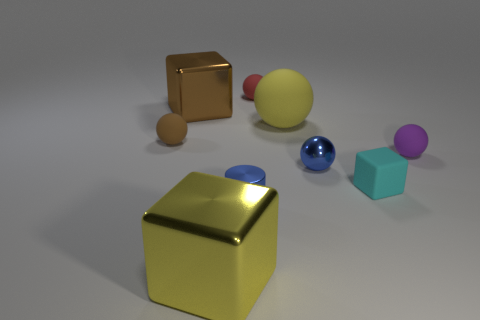Subtract all brown cubes. How many cubes are left? 2 Subtract all red balls. How many balls are left? 4 Add 1 purple objects. How many objects exist? 10 Subtract 2 cubes. How many cubes are left? 1 Subtract all cylinders. How many objects are left? 8 Subtract all green blocks. Subtract all green cylinders. How many blocks are left? 3 Subtract all large yellow blocks. Subtract all brown rubber balls. How many objects are left? 7 Add 3 red rubber objects. How many red rubber objects are left? 4 Add 5 small yellow shiny spheres. How many small yellow shiny spheres exist? 5 Subtract 0 purple cylinders. How many objects are left? 9 